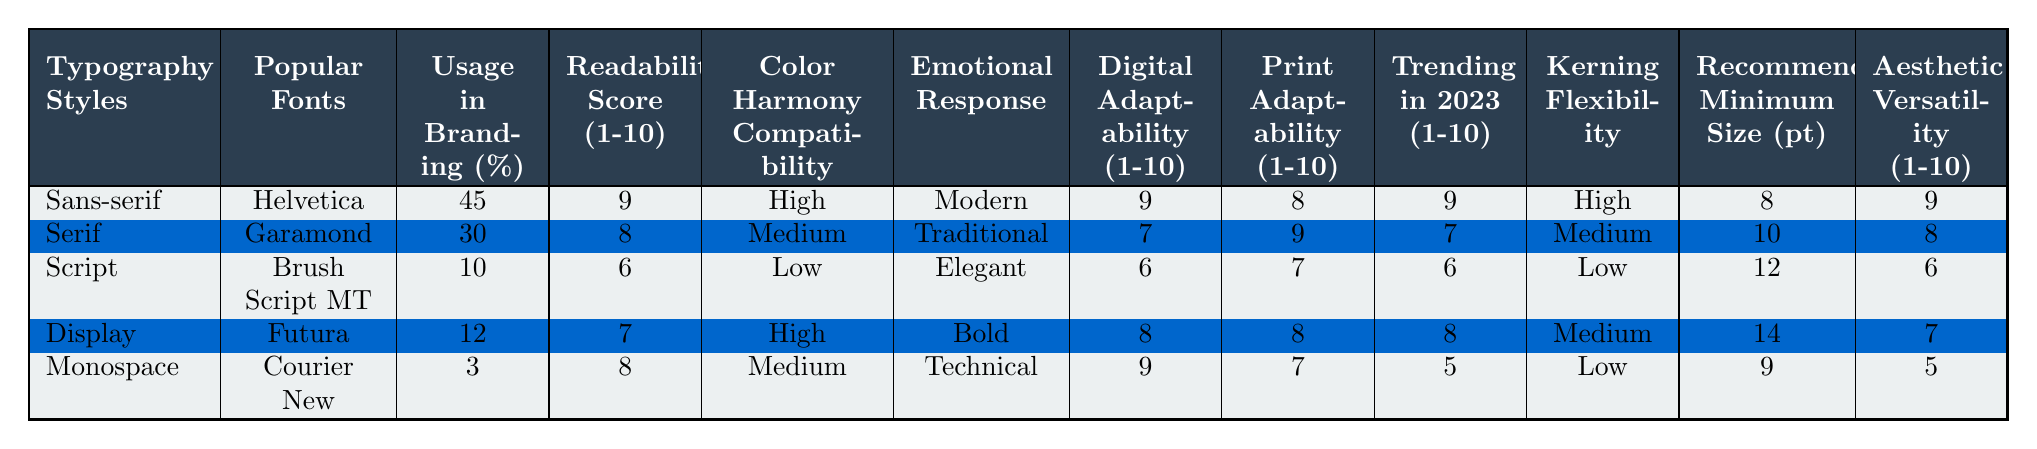What typography style has the highest usage in branding? The table indicates that Sans-serif has the highest usage in branding at 45%.
Answer: Sans-serif Which typography style is associated with a low readability score? The Script style is associated with a readability score of 6, which is the lowest in the table.
Answer: Script What is the emotional response associated with the Display typography style? According to the table, the emotional response for Display is "Bold."
Answer: Bold What is the average digital adaptability score for Serif and Display typography styles? The digital adaptability scores for Serif and Display are 7 and 8, respectively. The average is (7 + 8) / 2 = 7.5.
Answer: 7.5 Is it true that Monospace has a higher print adaptability score than Display? The print adaptability score for Monospace is 7, while for Display it is 8. Thus, this statement is false.
Answer: No What typography styles have a recommended minimum size greater than 10 points? The Serif and Display styles have recommended minimum sizes of 10 and 14 points, respectively.
Answer: Serif, Display Which typography style has the lowest emotional response listed? The Monospace style is associated with the emotional response "Technical," which is considered less expressive compared to the others.
Answer: Technical What is the median readability score for all typography styles? The readability scores are 9, 8, 6, 7, and 8, when ordered: 6, 7, 8, 8, 9; the median value (middle score) is 8.
Answer: 8 Which typography style is the least adaptable in terms of color harmony? The Script style is rated as having low color harmony compatibility.
Answer: Script How does the kerning flexibility of Sans-serif compare to Script? Sans-serif has high kerning flexibility, while Script has low kerning flexibility. Therefore, Sans-serif is more flexible than Script.
Answer: Higher 